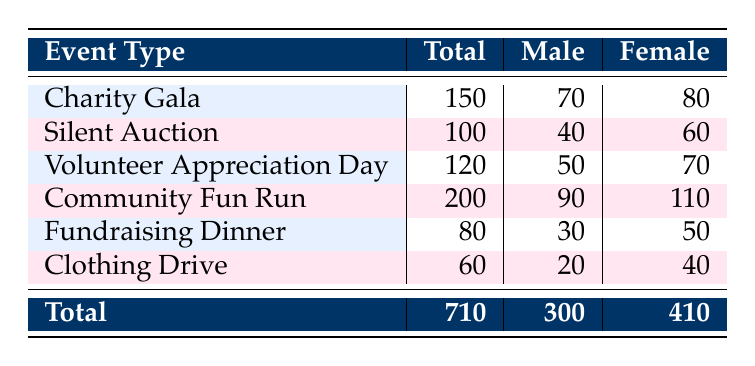What is the total attendance at the Charity Gala? The table lists the Charity Gala with a total attendance of 150.
Answer: 150 How many males attended the Silent Auction? The table shows that 40 males attended the Silent Auction event.
Answer: 40 What is the difference in female attendance between the Community Fun Run and the Fundraising Dinner? The Community Fun Run had 110 female attendees and the Fundraising Dinner had 50 female attendees. The difference is 110 - 50 = 60.
Answer: 60 True or False: More males attended the Volunteer Appreciation Day than the Fundraising Dinner. The table indicates 50 males attended the Volunteer Appreciation Day and 30 males attended the Fundraising Dinner. Therefore, the statement is true.
Answer: True What percentage of attendees at the Clothing Drive were female? The Clothing Drive had a total attendance of 60, with 40 of them being female. To find the percentage, calculate (40 / 60) * 100 = 66.67%.
Answer: 66.67% Which event had the highest total attendance and how many were female? The Community Fun Run had the highest total attendance of 200. It also had 110 females.
Answer: Community Fun Run: 110 If we combine the male attendees from the Charity Gala and the Silent Auction, what is the total? The Charity Gala had 70 male attendees and the Silent Auction had 40 male attendees, combining gives 70 + 40 = 110.
Answer: 110 What is the average attendance across all events for males? To find the average male attendance, first sum the male attendance: 70 + 40 + 50 + 90 + 30 + 20 = 300. There are 6 events, so the average is 300 / 6 = 50.
Answer: 50 Are there more females or males who attended the events combined? The total female attendance across all events is 410, while the total male attendance is 300. Since 410 > 300, there are more females.
Answer: Yes, more females attended What is the total number of attendees across all events? To find the total attendance, sum all the total attendance figures: 150 + 100 + 120 + 200 + 80 + 60 = 710.
Answer: 710 